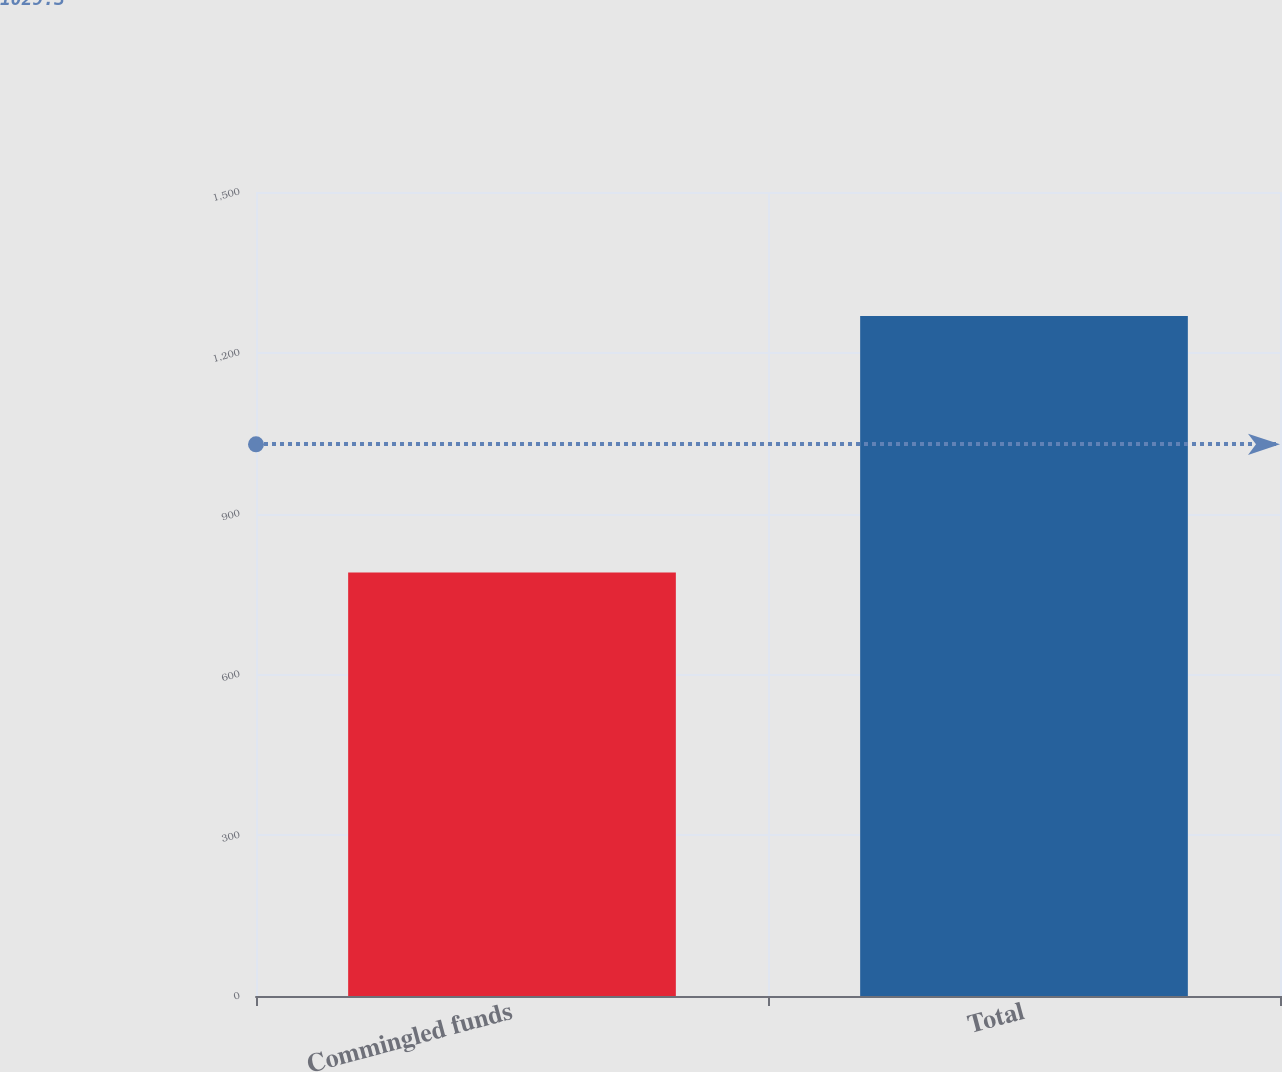Convert chart to OTSL. <chart><loc_0><loc_0><loc_500><loc_500><bar_chart><fcel>Commingled funds<fcel>Total<nl><fcel>790.1<fcel>1268.5<nl></chart> 